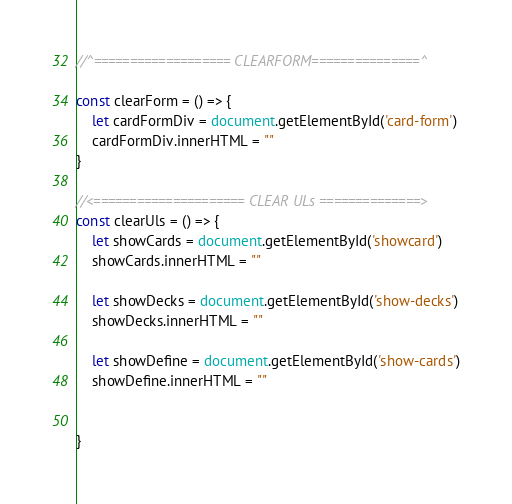<code> <loc_0><loc_0><loc_500><loc_500><_JavaScript_>//^=================== CLEARFORM===============^

const clearForm = () => {
    let cardFormDiv = document.getElementById('card-form')
    cardFormDiv.innerHTML = ""
}

//<===================== CLEAR ULs ==============>
const clearUls = () => {
    let showCards = document.getElementById('showcard')
    showCards.innerHTML = ""

    let showDecks = document.getElementById('show-decks')
    showDecks.innerHTML = ""

    let showDefine = document.getElementById('show-cards')
    showDefine.innerHTML = ""

    
}</code> 